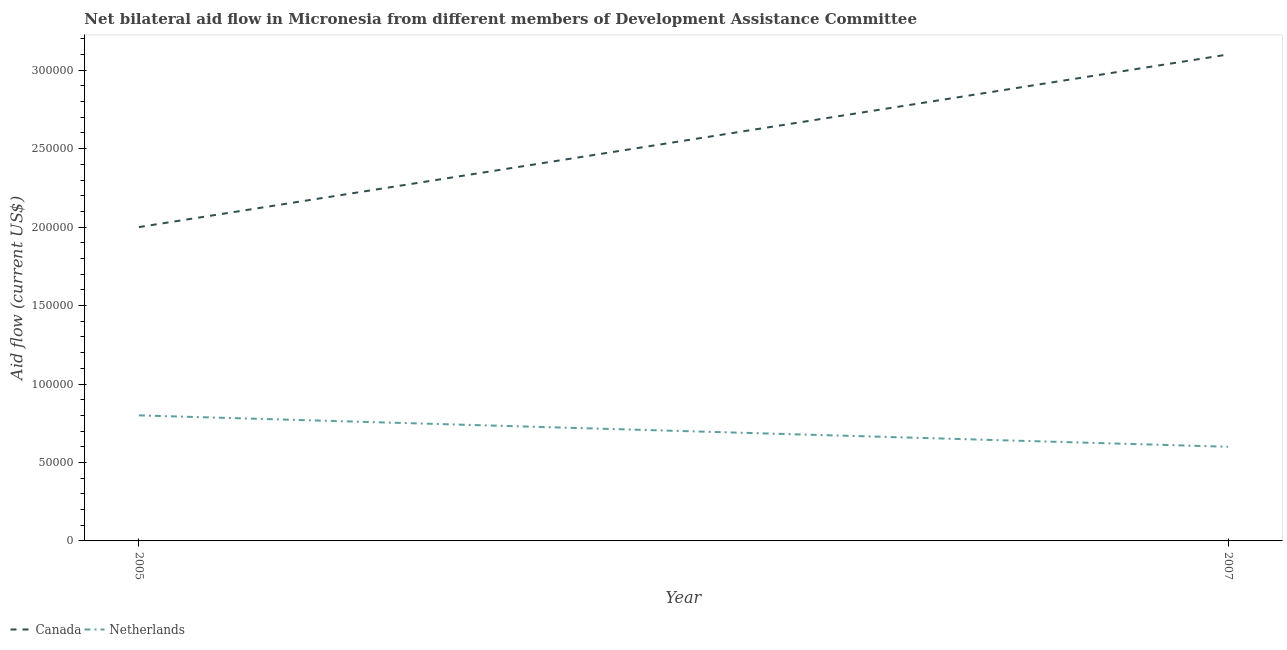How many different coloured lines are there?
Provide a short and direct response. 2. Does the line corresponding to amount of aid given by canada intersect with the line corresponding to amount of aid given by netherlands?
Provide a succinct answer. No. Is the number of lines equal to the number of legend labels?
Your response must be concise. Yes. What is the amount of aid given by netherlands in 2007?
Offer a very short reply. 6.00e+04. Across all years, what is the maximum amount of aid given by netherlands?
Your answer should be compact. 8.00e+04. Across all years, what is the minimum amount of aid given by canada?
Provide a short and direct response. 2.00e+05. What is the total amount of aid given by canada in the graph?
Give a very brief answer. 5.10e+05. What is the difference between the amount of aid given by netherlands in 2005 and that in 2007?
Offer a terse response. 2.00e+04. What is the difference between the amount of aid given by netherlands in 2007 and the amount of aid given by canada in 2005?
Your answer should be compact. -1.40e+05. What is the average amount of aid given by netherlands per year?
Provide a short and direct response. 7.00e+04. In the year 2007, what is the difference between the amount of aid given by netherlands and amount of aid given by canada?
Your response must be concise. -2.50e+05. In how many years, is the amount of aid given by canada greater than 180000 US$?
Offer a terse response. 2. What is the ratio of the amount of aid given by netherlands in 2005 to that in 2007?
Provide a short and direct response. 1.33. Is the amount of aid given by canada in 2005 less than that in 2007?
Make the answer very short. Yes. In how many years, is the amount of aid given by netherlands greater than the average amount of aid given by netherlands taken over all years?
Provide a short and direct response. 1. Is the amount of aid given by canada strictly greater than the amount of aid given by netherlands over the years?
Your response must be concise. Yes. How many lines are there?
Provide a succinct answer. 2. What is the difference between two consecutive major ticks on the Y-axis?
Your answer should be compact. 5.00e+04. Are the values on the major ticks of Y-axis written in scientific E-notation?
Give a very brief answer. No. Does the graph contain any zero values?
Your response must be concise. No. Does the graph contain grids?
Offer a terse response. No. What is the title of the graph?
Offer a very short reply. Net bilateral aid flow in Micronesia from different members of Development Assistance Committee. Does "Urban Population" appear as one of the legend labels in the graph?
Your answer should be compact. No. What is the label or title of the Y-axis?
Your response must be concise. Aid flow (current US$). What is the Aid flow (current US$) of Canada in 2005?
Your answer should be very brief. 2.00e+05. What is the Aid flow (current US$) in Netherlands in 2005?
Give a very brief answer. 8.00e+04. What is the Aid flow (current US$) in Netherlands in 2007?
Keep it short and to the point. 6.00e+04. Across all years, what is the maximum Aid flow (current US$) in Canada?
Provide a succinct answer. 3.10e+05. Across all years, what is the minimum Aid flow (current US$) in Canada?
Give a very brief answer. 2.00e+05. Across all years, what is the minimum Aid flow (current US$) of Netherlands?
Give a very brief answer. 6.00e+04. What is the total Aid flow (current US$) in Canada in the graph?
Provide a succinct answer. 5.10e+05. What is the difference between the Aid flow (current US$) in Netherlands in 2005 and that in 2007?
Make the answer very short. 2.00e+04. What is the difference between the Aid flow (current US$) of Canada in 2005 and the Aid flow (current US$) of Netherlands in 2007?
Your answer should be very brief. 1.40e+05. What is the average Aid flow (current US$) in Canada per year?
Provide a succinct answer. 2.55e+05. What is the ratio of the Aid flow (current US$) of Canada in 2005 to that in 2007?
Provide a succinct answer. 0.65. What is the ratio of the Aid flow (current US$) in Netherlands in 2005 to that in 2007?
Give a very brief answer. 1.33. What is the difference between the highest and the second highest Aid flow (current US$) in Netherlands?
Your answer should be very brief. 2.00e+04. What is the difference between the highest and the lowest Aid flow (current US$) of Netherlands?
Ensure brevity in your answer.  2.00e+04. 